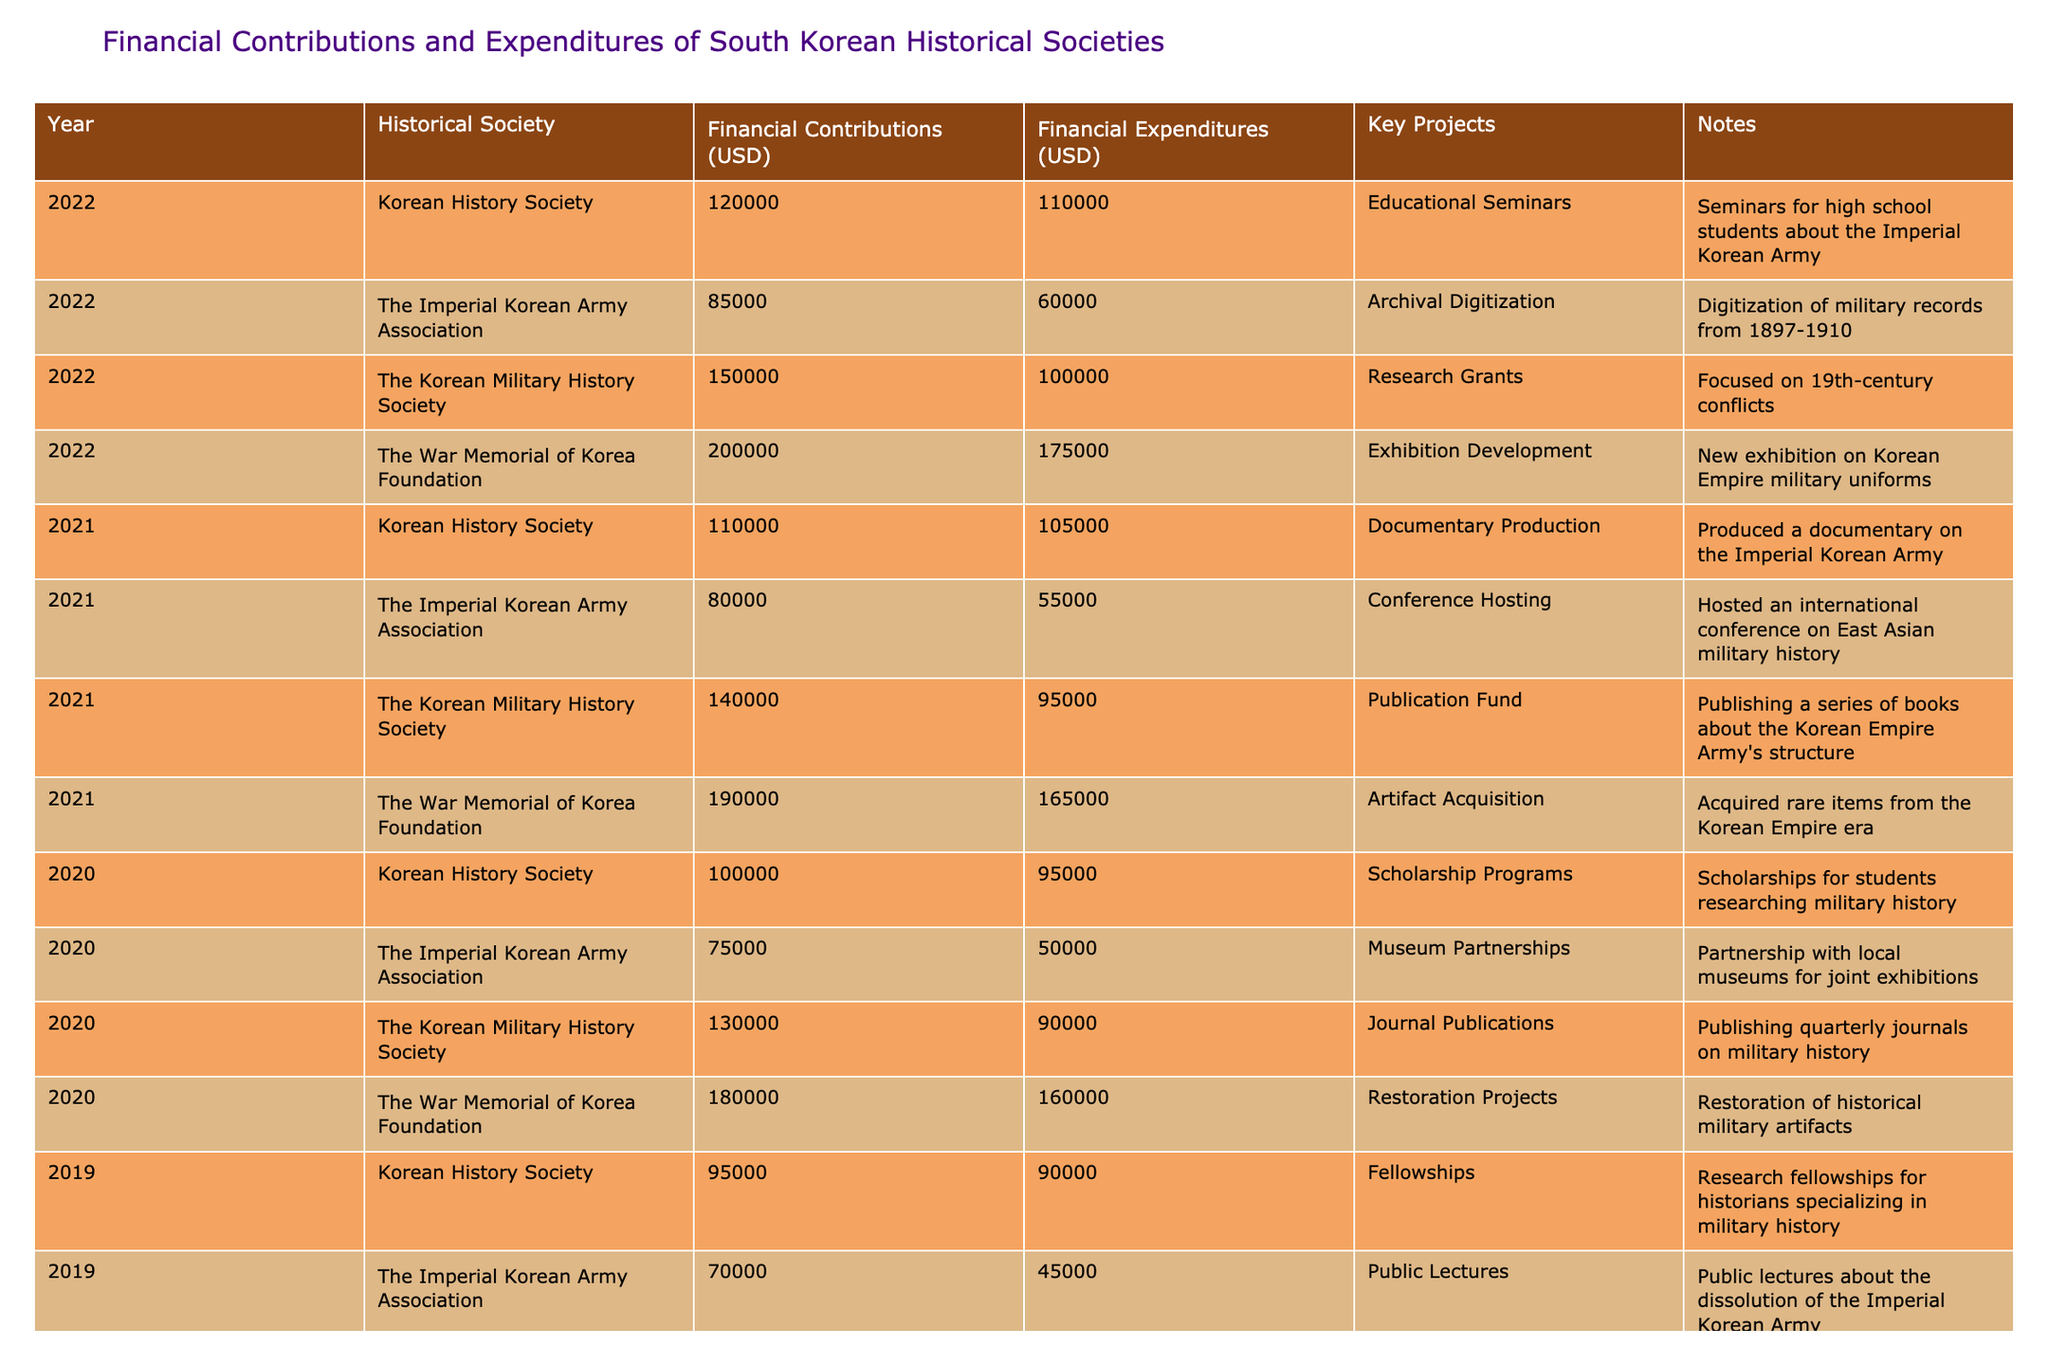What were the financial contributions of The War Memorial of Korea Foundation in 2022? Referring to the table, in 2022, the financial contributions from The War Memorial of Korea Foundation were listed as 200,000 USD.
Answer: 200000 What was the total financial expenditure of The Imperial Korean Army Association across all years listed in the table? To find the total for The Imperial Korean Army Association, we sum the expenditures from each year: 60,000 (2022) + 55,000 (2021) + 50,000 (2020) + 45,000 (2019) = 210,000 USD.
Answer: 210000 Did The Korean Military History Society spend more than it contributed in 2021? In the table, The Korean Military History Society's contributions in 2021 were 140,000 USD, while expenditures were 95,000 USD. Since contributions exceeded expenditures, the answer is no.
Answer: No Which society had the highest financial contribution in 2020? Checking the table, the financial contributions for 2020 are: The Korean Military History Society (130,000), The Imperial Korean Army Association (75,000), The War Memorial of Korea Foundation (180,000), and Korean History Society (100,000). The War Memorial of Korea Foundation had the highest contribution at 180,000 USD.
Answer: The War Memorial of Korea Foundation What is the average financial expenditure of the historical societies across all years in the given data? The total expenditure across all entries can be calculated: 100,000 (2022) + 60,000 (2022) + 175,000 (2022) + 110,000 (2022) + 95,000 (2021) + 55,000 (2021) + 165,000 (2021) + 105,000 (2021) + 90,000 (2020) + 50,000 (2020) + 160,000 (2020) + 95,000 (2020) + 85,000 (2019) + 45,000 (2019) + 155,000 (2019) + 90,000 (2019) = 1,545,000. There are 16 entries (4 societies over 4 years), so the average is 1,545,000 / 16 = 96,562.50.
Answer: 96562.50 What key project did the Korean History Society undertake in 2022? According to the table, in 2022, the Korean History Society focused on Educational Seminars as their key project.
Answer: Educational Seminars 